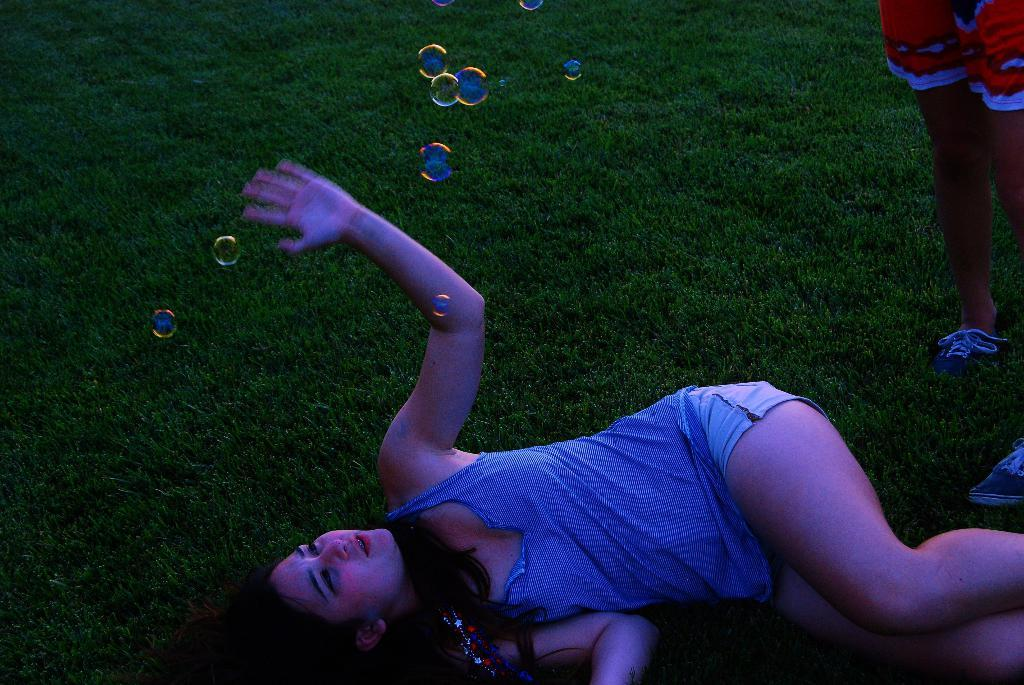What is the woman in the foreground of the image doing? The woman is lying on the grass in the foreground of the image. What can be seen floating in the air in the image? There are bubbles in the air in the image. Can you describe the legs of a person visible on the right side of the image? Yes, there are legs of a person on the right side of the image. What type of shop can be seen in the background of the image? There is no shop visible in the image; it only features a woman lying on the grass, bubbles in the air, and legs of a person. 